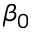<formula> <loc_0><loc_0><loc_500><loc_500>\beta _ { 0 }</formula> 